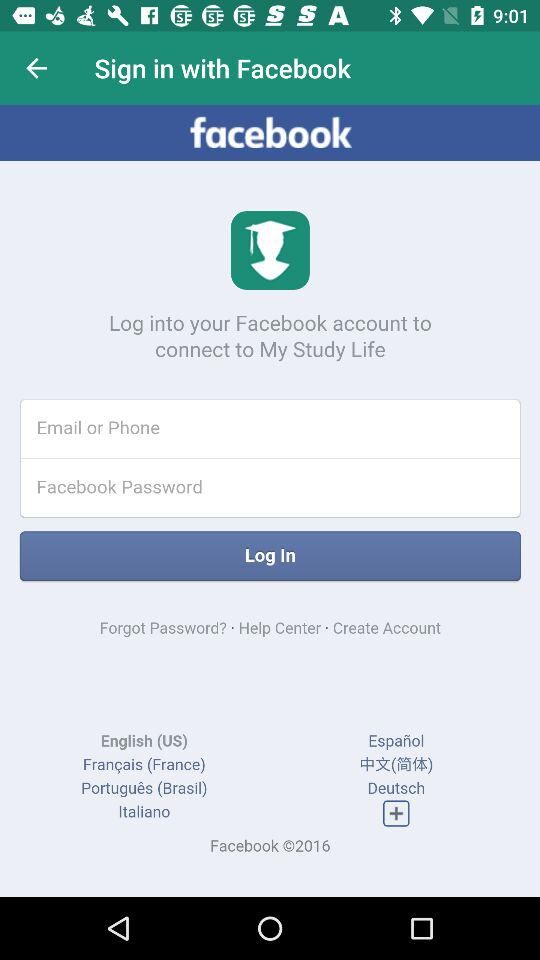What is the copyright year? The copyright year is 2016. 